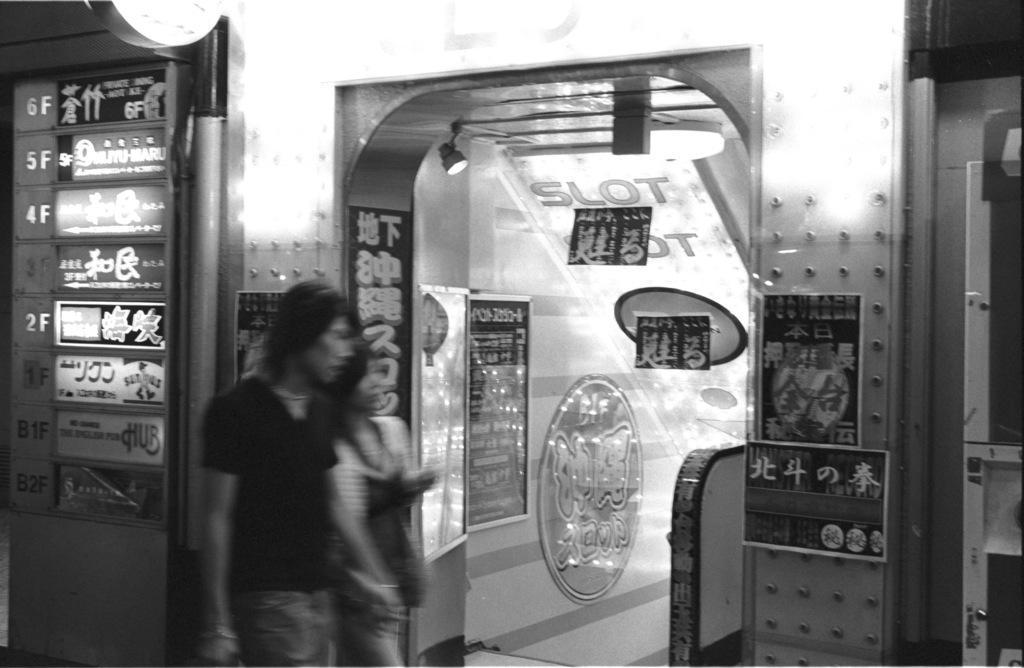In one or two sentences, can you explain what this image depicts? This is a black and white picture. I can see two persons standing, boards, lights and some other objects. There are posters attached to the walls. 